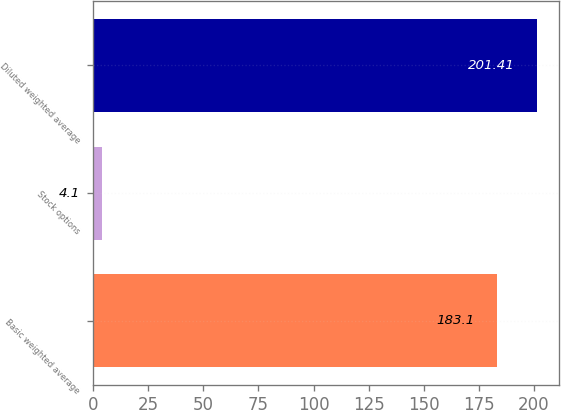Convert chart to OTSL. <chart><loc_0><loc_0><loc_500><loc_500><bar_chart><fcel>Basic weighted average<fcel>Stock options<fcel>Diluted weighted average<nl><fcel>183.1<fcel>4.1<fcel>201.41<nl></chart> 